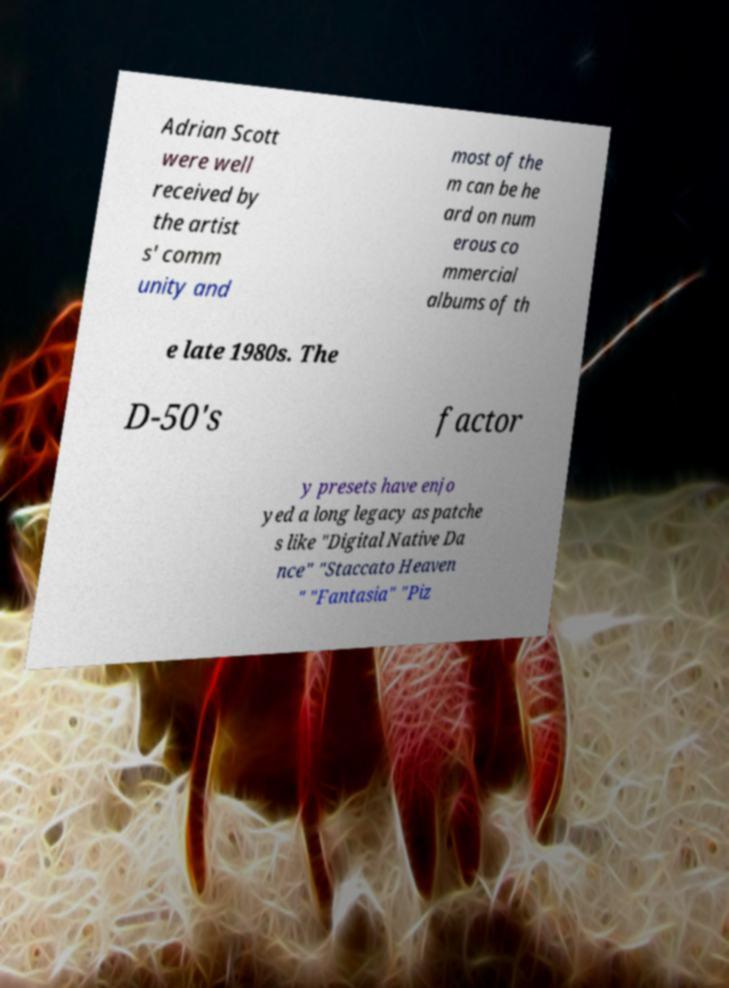Can you read and provide the text displayed in the image?This photo seems to have some interesting text. Can you extract and type it out for me? Adrian Scott were well received by the artist s' comm unity and most of the m can be he ard on num erous co mmercial albums of th e late 1980s. The D-50's factor y presets have enjo yed a long legacy as patche s like "Digital Native Da nce" "Staccato Heaven " "Fantasia" "Piz 